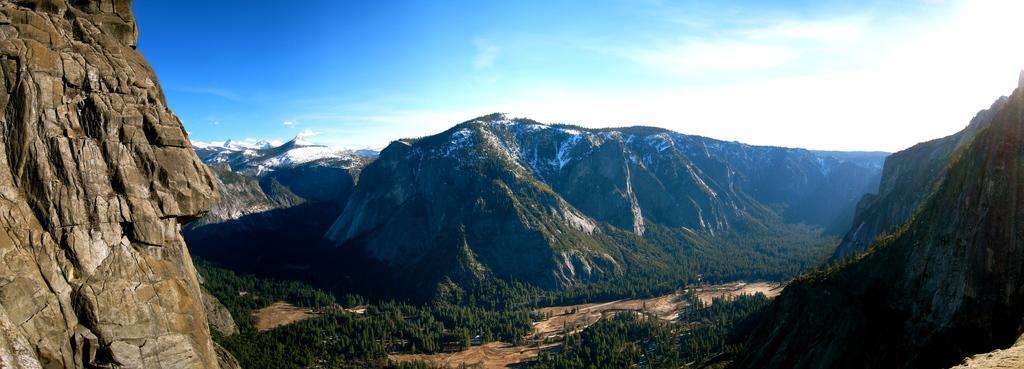How would you summarize this image in a sentence or two? In this image we can see the trees, hills and also the mountains. We can also the sky with the clouds. 